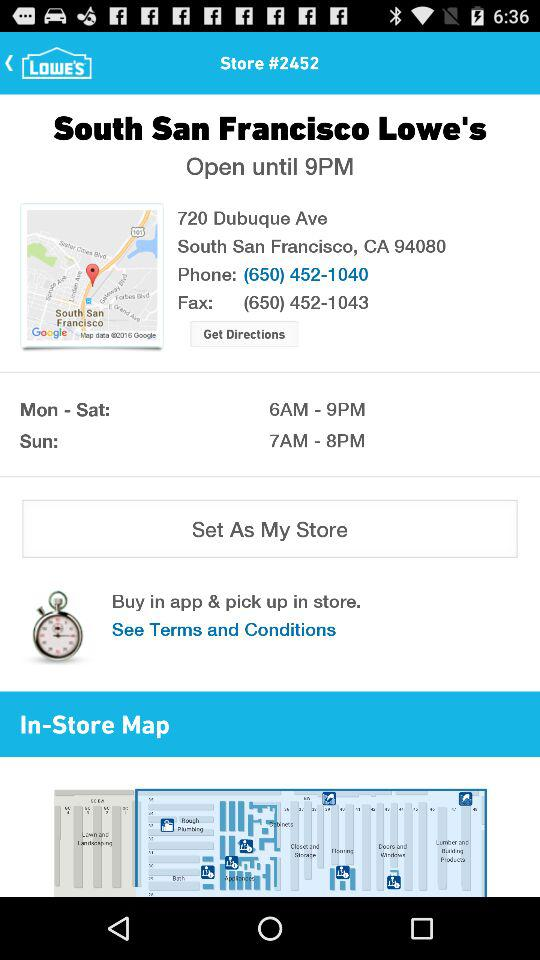What is the opening time from Monday to Saturday? The opening time is 6 a.m. 